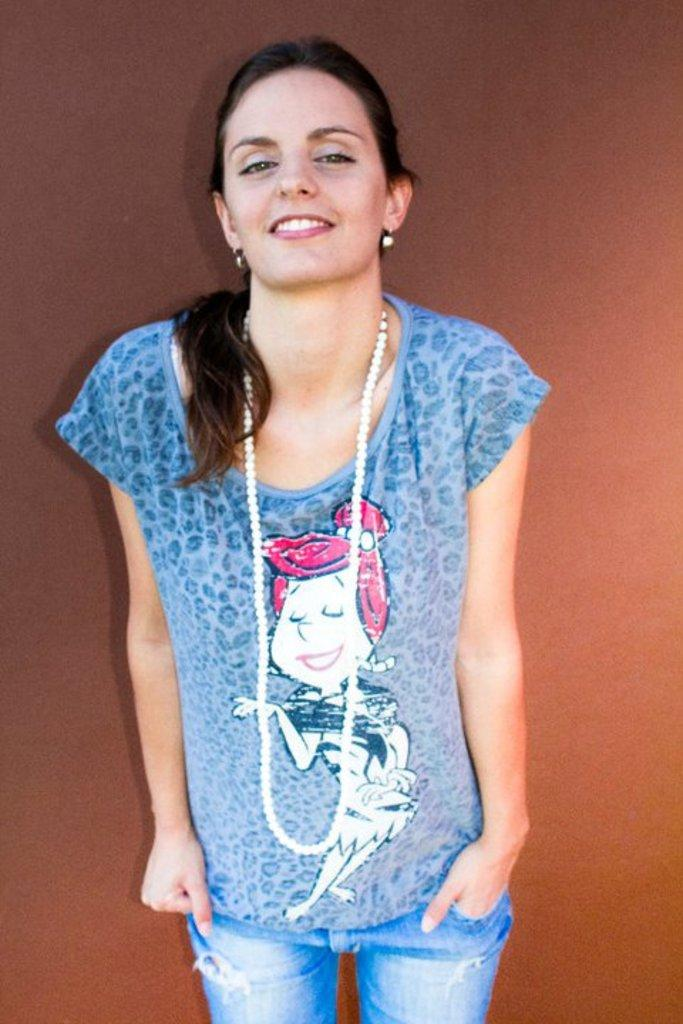Who is present in the image? There is a woman in the picture. What is the woman doing in the image? The woman is standing in the image. What is the woman's facial expression in the image? The woman is smiling in the image. What is the color of the background in the image? The background in the image is light brown. What type of vegetable is the woman holding in the image? There is no vegetable present in the image; the woman is not holding anything. Can you tell me how many snakes are visible in the image? There are no snakes present in the image. 